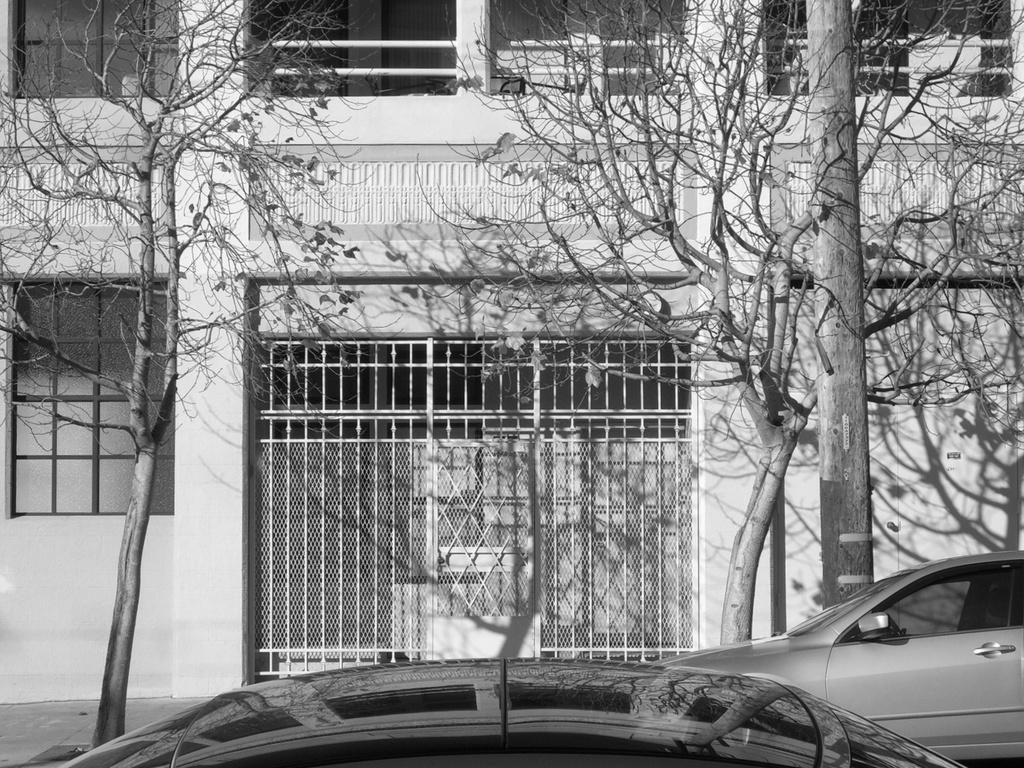What is the color scheme of the image? The image is black and white. What type of vehicles can be seen in the image? There are cars in the image. What type of natural elements are present in the image? There are trees in the image. What man-made structure can be seen in the image? There is a pole in the image. What type of background is visible in the image? There is a building in the background of the image. Can you tell me how many snails are crawling on the building in the image? There are no snails present in the image; it only features cars, trees, a pole, and a building. What type of growth can be seen on the trees in the image? The image is black and white, so it is difficult to determine the type of growth on the trees. 